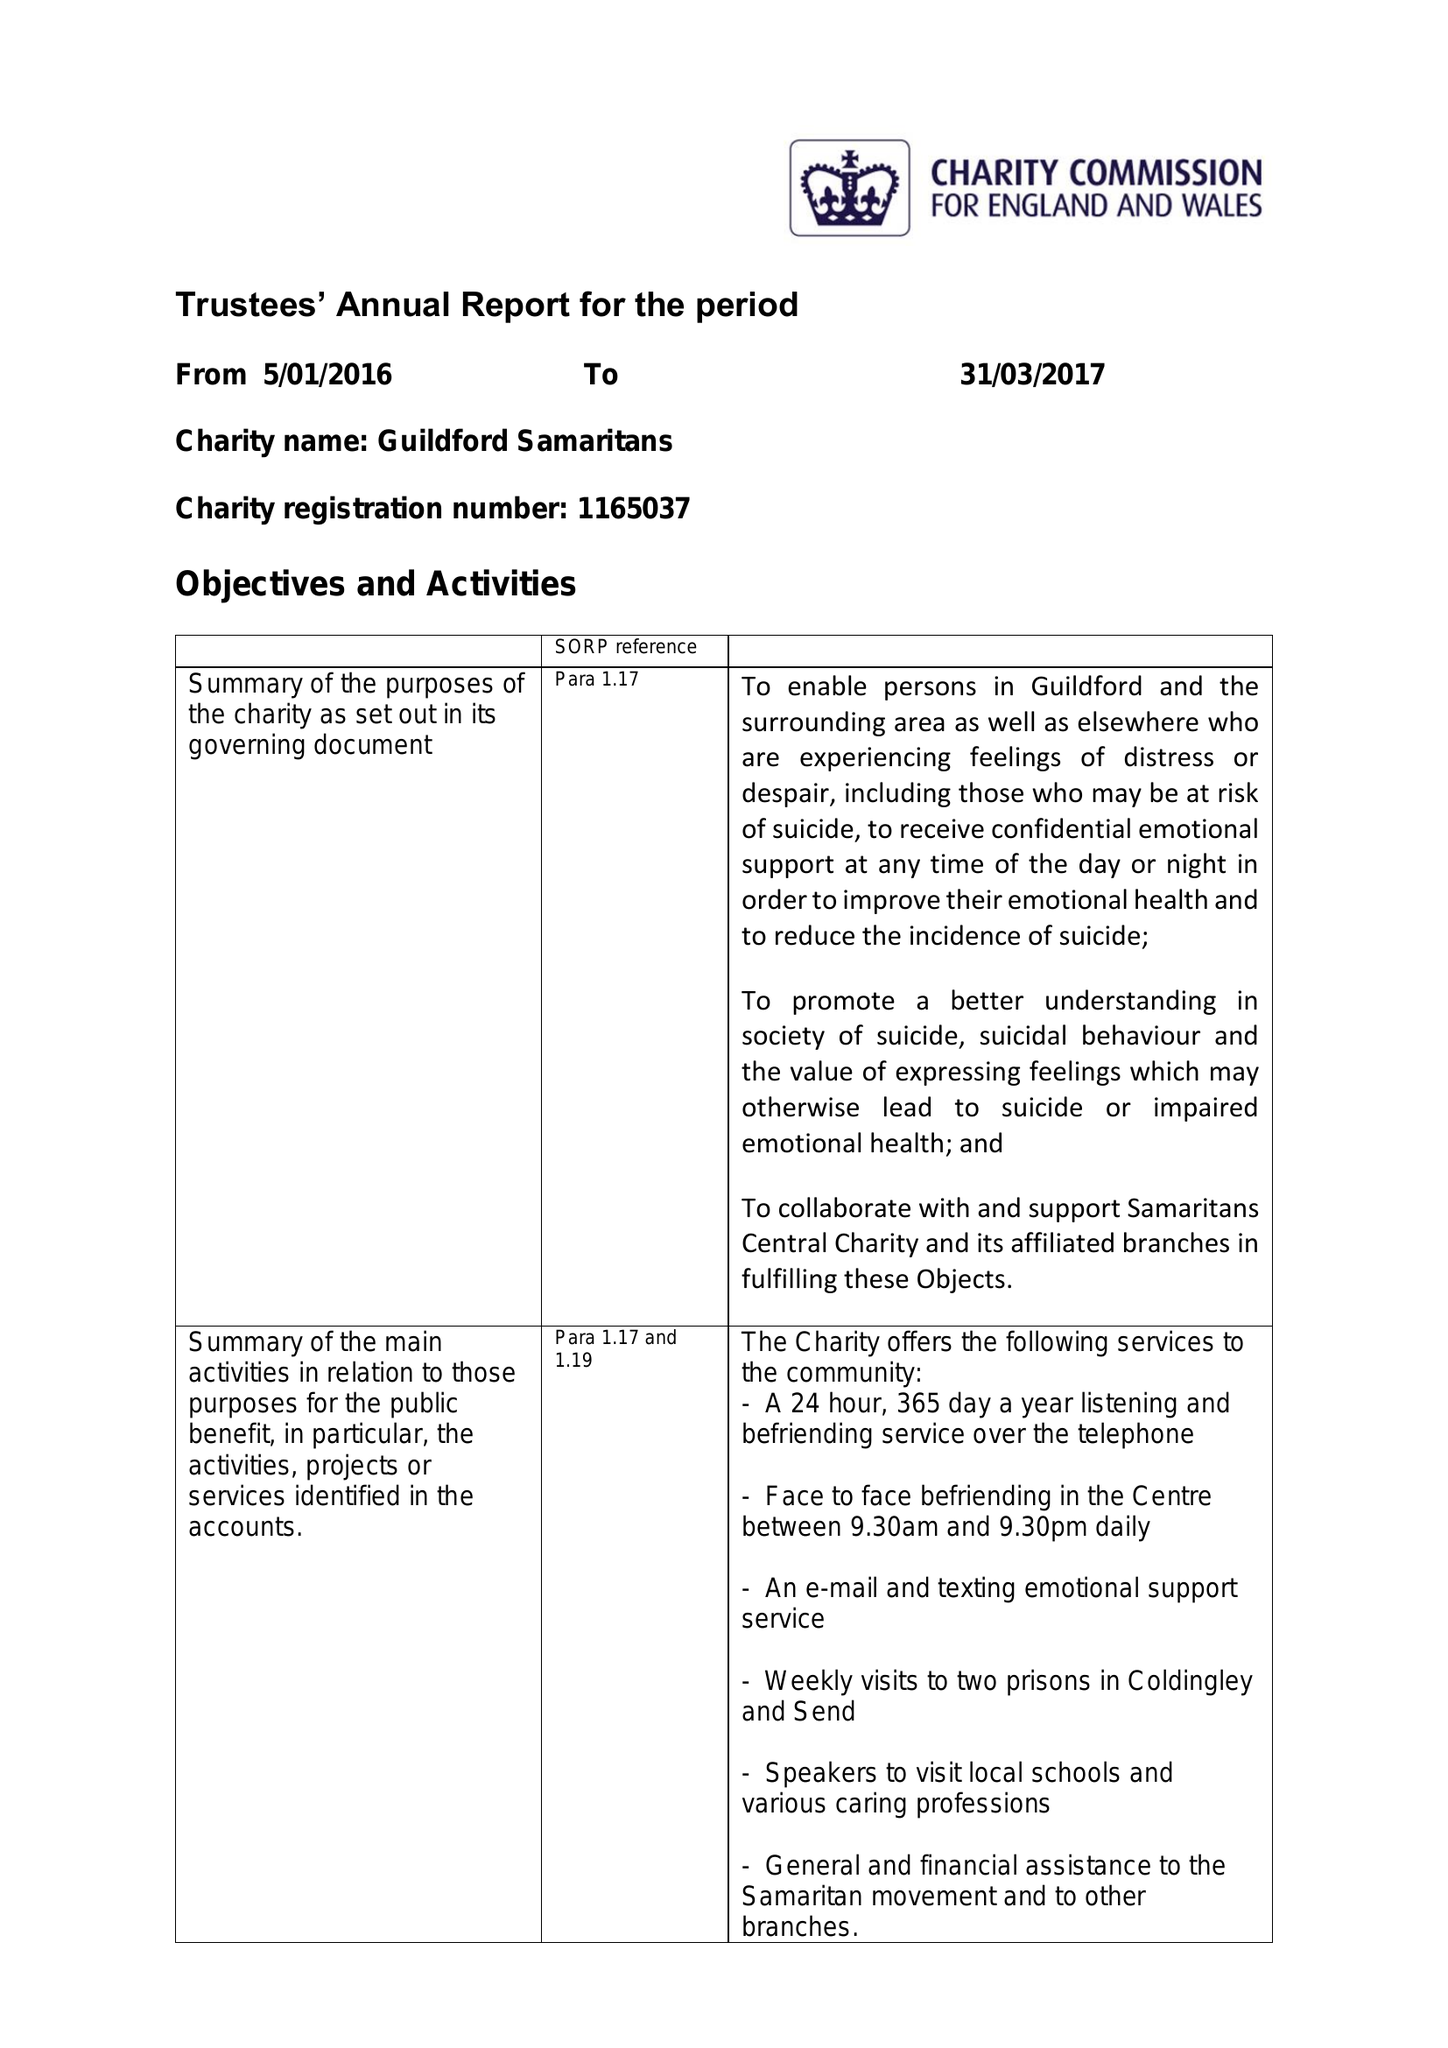What is the value for the address__street_line?
Answer the question using a single word or phrase. 69 WOODBRIDGE ROAD 